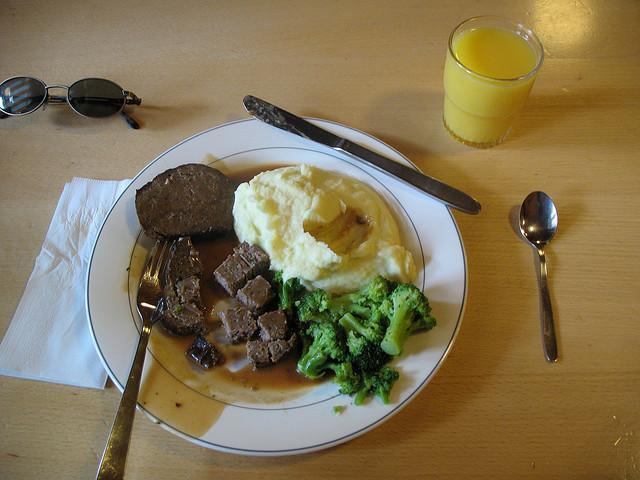How many spoons are present?
Give a very brief answer. 1. How many forks are there?
Give a very brief answer. 1. How many spoons are there?
Give a very brief answer. 1. How many forks can be seen?
Give a very brief answer. 1. 